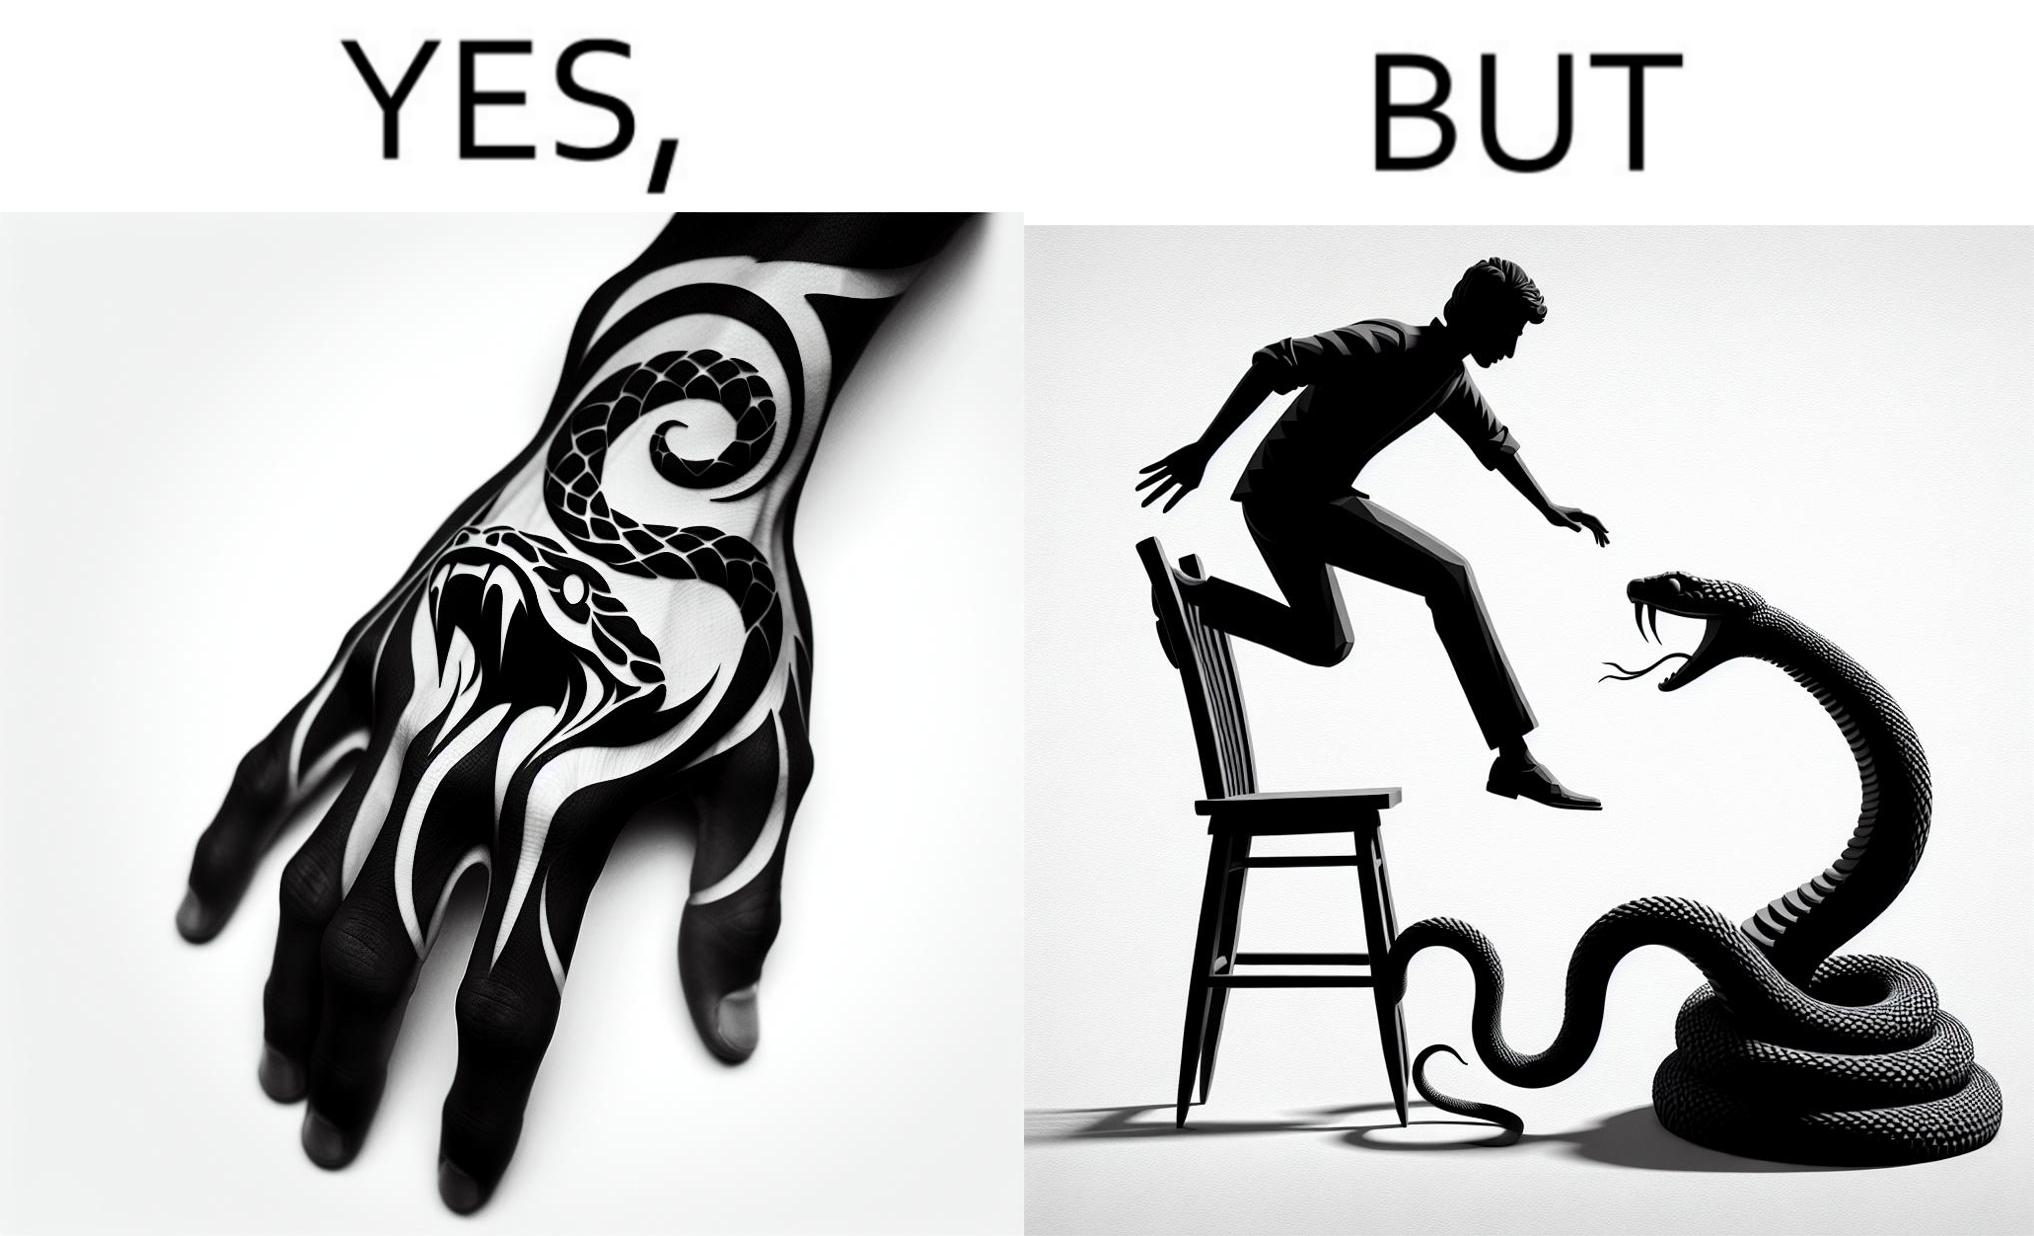What is shown in the left half versus the right half of this image? In the left part of the image: a tattoo of a snake with its mouth wide open on someone's hand In the right part of the image: a person standing on a chair trying save himself from the attack of snake and the snake is probably trying to climb up the chair 